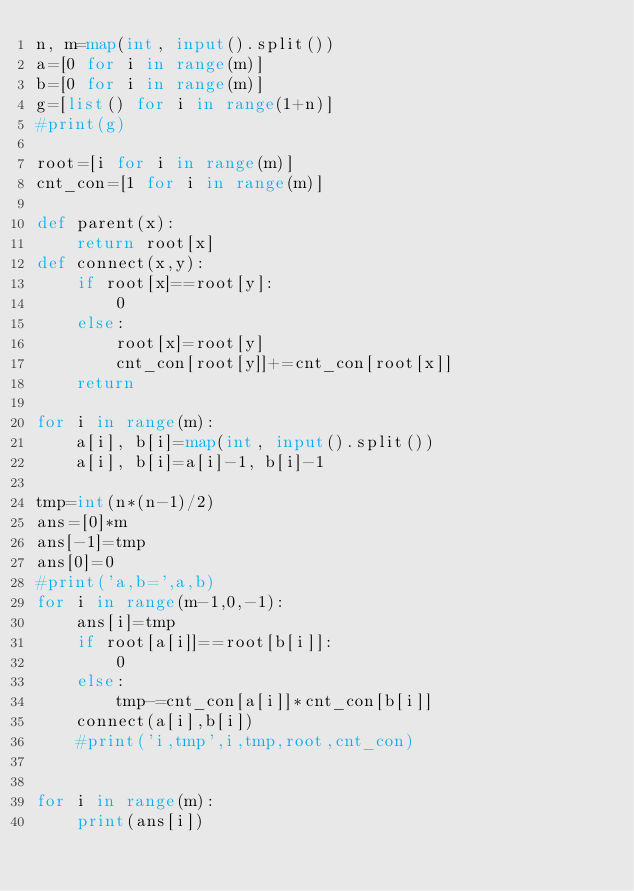<code> <loc_0><loc_0><loc_500><loc_500><_Python_>n, m=map(int, input().split())
a=[0 for i in range(m)]
b=[0 for i in range(m)]
g=[list() for i in range(1+n)]
#print(g)

root=[i for i in range(m)]
cnt_con=[1 for i in range(m)]

def parent(x):
    return root[x]
def connect(x,y):
    if root[x]==root[y]:
        0
    else:
        root[x]=root[y]
        cnt_con[root[y]]+=cnt_con[root[x]]
    return

for i in range(m):
    a[i], b[i]=map(int, input().split())
    a[i], b[i]=a[i]-1, b[i]-1

tmp=int(n*(n-1)/2)
ans=[0]*m
ans[-1]=tmp
ans[0]=0
#print('a,b=',a,b)
for i in range(m-1,0,-1):
    ans[i]=tmp
    if root[a[i]]==root[b[i]]:
        0
    else:
        tmp-=cnt_con[a[i]]*cnt_con[b[i]]
    connect(a[i],b[i])
    #print('i,tmp',i,tmp,root,cnt_con)
        
    
for i in range(m):
    print(ans[i])</code> 